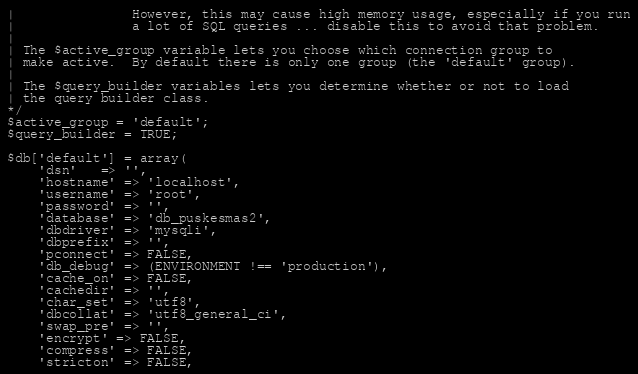Convert code to text. <code><loc_0><loc_0><loc_500><loc_500><_PHP_>| 				However, this may cause high memory usage, especially if you run
| 				a lot of SQL queries ... disable this to avoid that problem.
|
| The $active_group variable lets you choose which connection group to
| make active.  By default there is only one group (the 'default' group).
|
| The $query_builder variables lets you determine whether or not to load
| the query builder class.
*/
$active_group = 'default';
$query_builder = TRUE;

$db['default'] = array(
	'dsn'	=> '',
	'hostname' => 'localhost',
	'username' => 'root',
	'password' => '',
	'database' => 'db_puskesmas2',
	'dbdriver' => 'mysqli',
	'dbprefix' => '',
	'pconnect' => FALSE,
	'db_debug' => (ENVIRONMENT !== 'production'),
	'cache_on' => FALSE,
	'cachedir' => '',
	'char_set' => 'utf8',
	'dbcollat' => 'utf8_general_ci',
	'swap_pre' => '',
	'encrypt' => FALSE,
	'compress' => FALSE,
	'stricton' => FALSE,</code> 